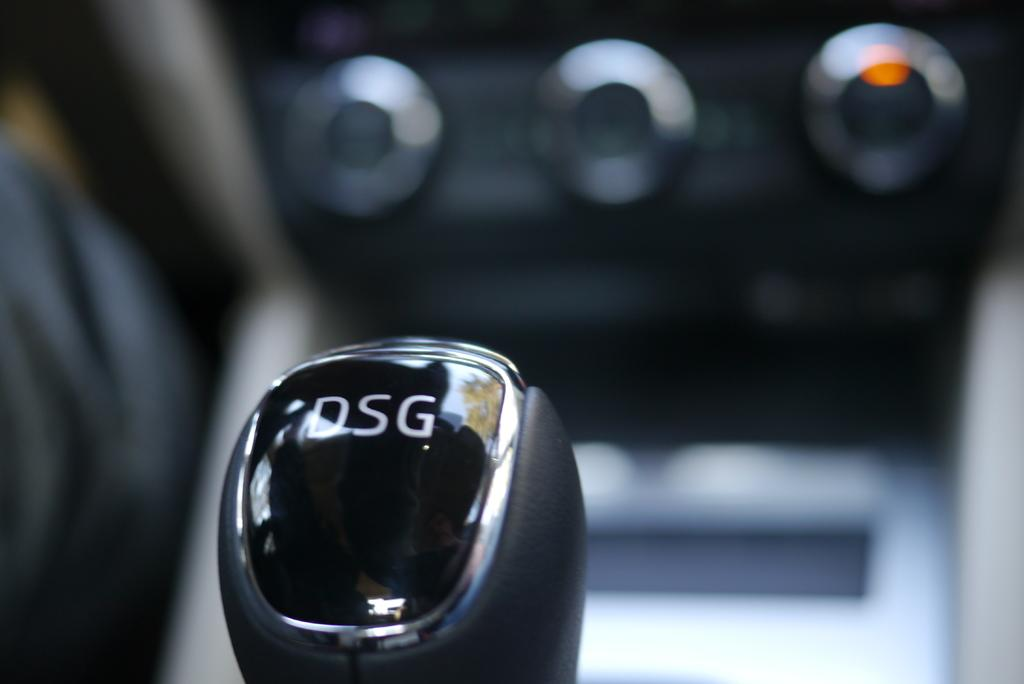What is the main setting of the image? The image shows the inside view of a car. What can be found at the front bottom side of the car? There is a gear handle in the front bottom side of the car. How would you describe the background of the image? The background is blurred. What is located in the center of the car? There is a center console unit in the car. How many beds can be seen in the image? There are no beds present in the image; it shows the inside view of a car. What type of spark is visible on the gear handle? There is no spark visible on the gear handle in the image. 